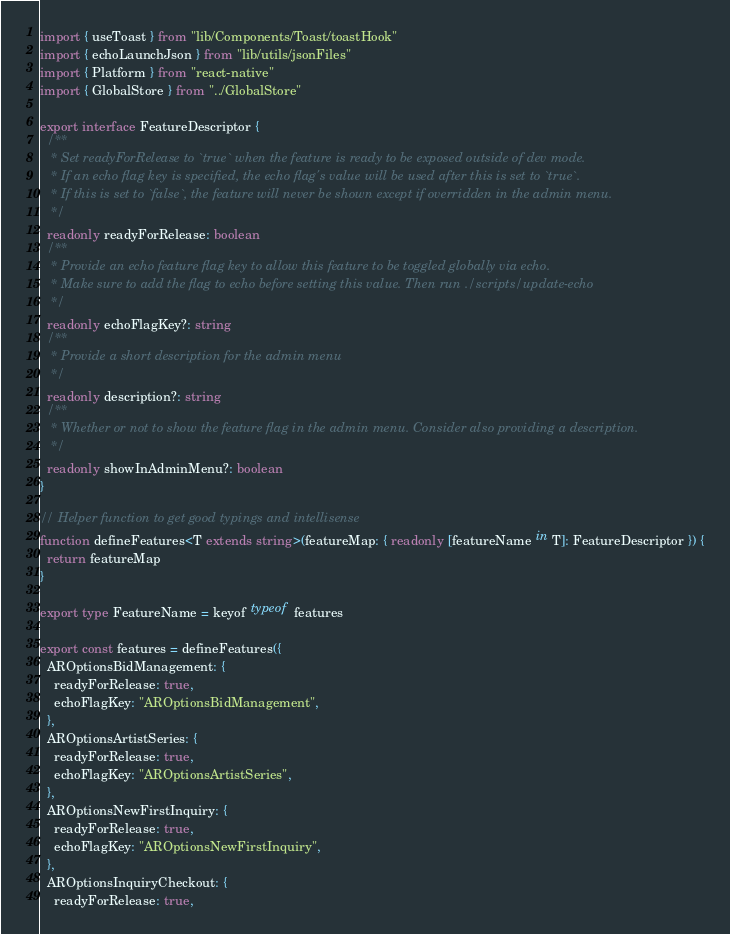Convert code to text. <code><loc_0><loc_0><loc_500><loc_500><_TypeScript_>import { useToast } from "lib/Components/Toast/toastHook"
import { echoLaunchJson } from "lib/utils/jsonFiles"
import { Platform } from "react-native"
import { GlobalStore } from "../GlobalStore"

export interface FeatureDescriptor {
  /**
   * Set readyForRelease to `true` when the feature is ready to be exposed outside of dev mode.
   * If an echo flag key is specified, the echo flag's value will be used after this is set to `true`.
   * If this is set to `false`, the feature will never be shown except if overridden in the admin menu.
   */
  readonly readyForRelease: boolean
  /**
   * Provide an echo feature flag key to allow this feature to be toggled globally via echo.
   * Make sure to add the flag to echo before setting this value. Then run ./scripts/update-echo
   */
  readonly echoFlagKey?: string
  /**
   * Provide a short description for the admin menu
   */
  readonly description?: string
  /**
   * Whether or not to show the feature flag in the admin menu. Consider also providing a description.
   */
  readonly showInAdminMenu?: boolean
}

// Helper function to get good typings and intellisense
function defineFeatures<T extends string>(featureMap: { readonly [featureName in T]: FeatureDescriptor }) {
  return featureMap
}

export type FeatureName = keyof typeof features

export const features = defineFeatures({
  AROptionsBidManagement: {
    readyForRelease: true,
    echoFlagKey: "AROptionsBidManagement",
  },
  AROptionsArtistSeries: {
    readyForRelease: true,
    echoFlagKey: "AROptionsArtistSeries",
  },
  AROptionsNewFirstInquiry: {
    readyForRelease: true,
    echoFlagKey: "AROptionsNewFirstInquiry",
  },
  AROptionsInquiryCheckout: {
    readyForRelease: true,</code> 